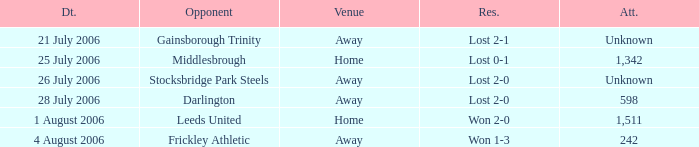What is the attendance rate for the Middlesbrough opponent? 1342.0. 